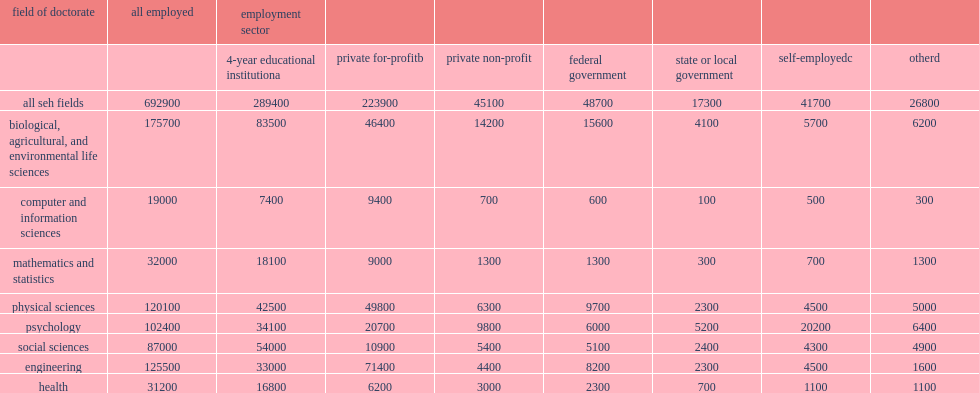How many percent did four-year educational institutions employ of all working seh doctorate recipients in 2010? 0.417665. How many percent of employment in 4-year educational institutions which was most common for doctorate recipients in the social sciences? 0.62069. 